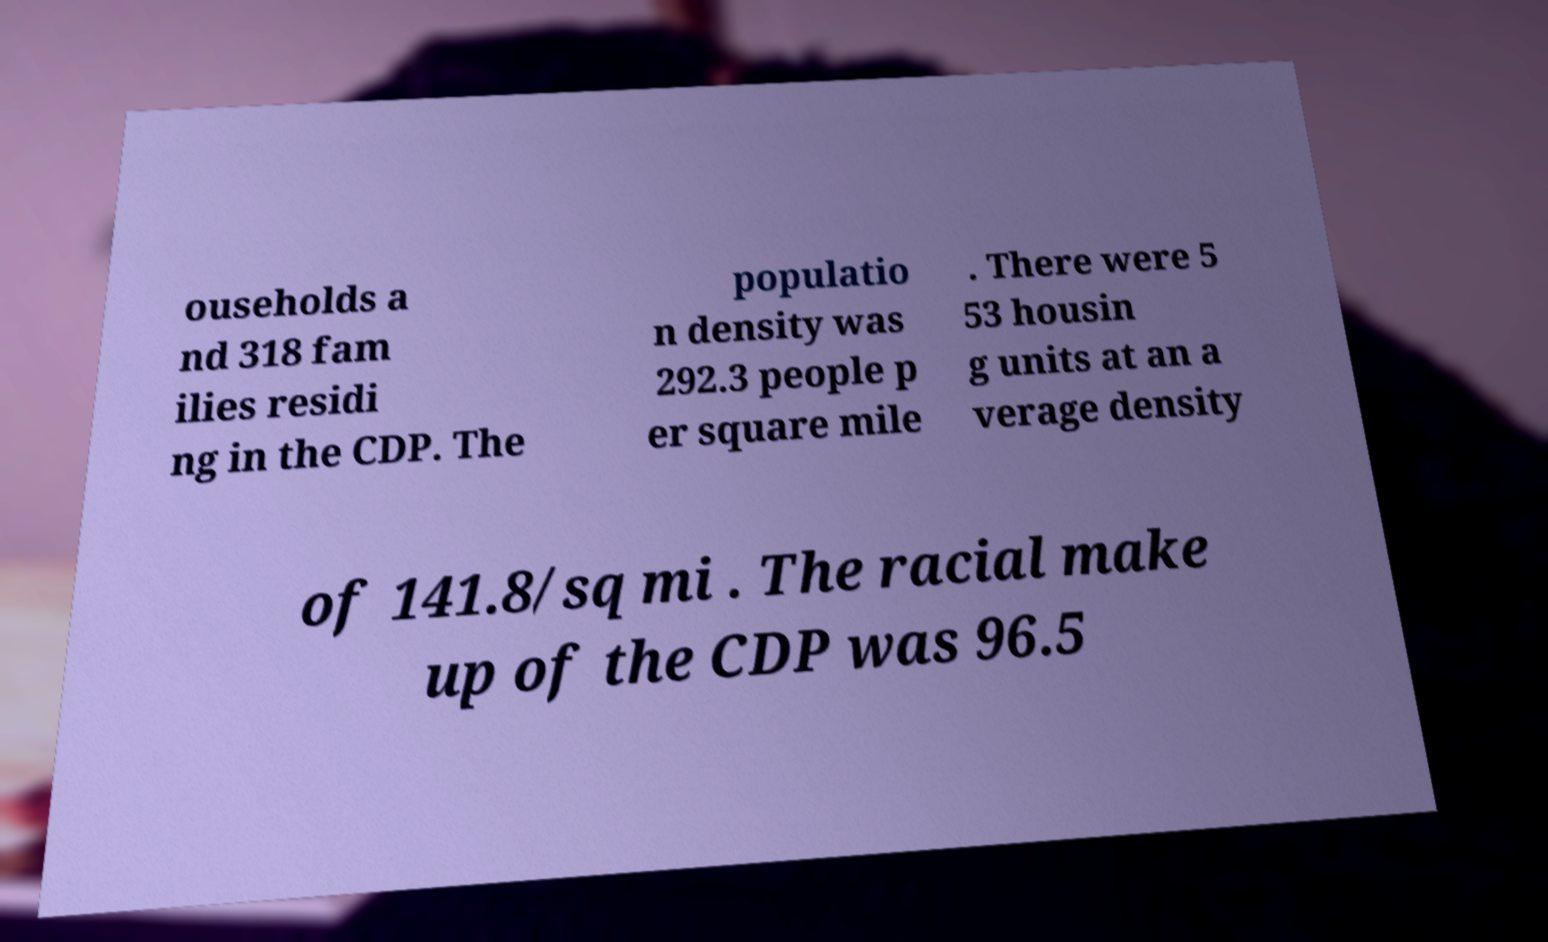There's text embedded in this image that I need extracted. Can you transcribe it verbatim? ouseholds a nd 318 fam ilies residi ng in the CDP. The populatio n density was 292.3 people p er square mile . There were 5 53 housin g units at an a verage density of 141.8/sq mi . The racial make up of the CDP was 96.5 